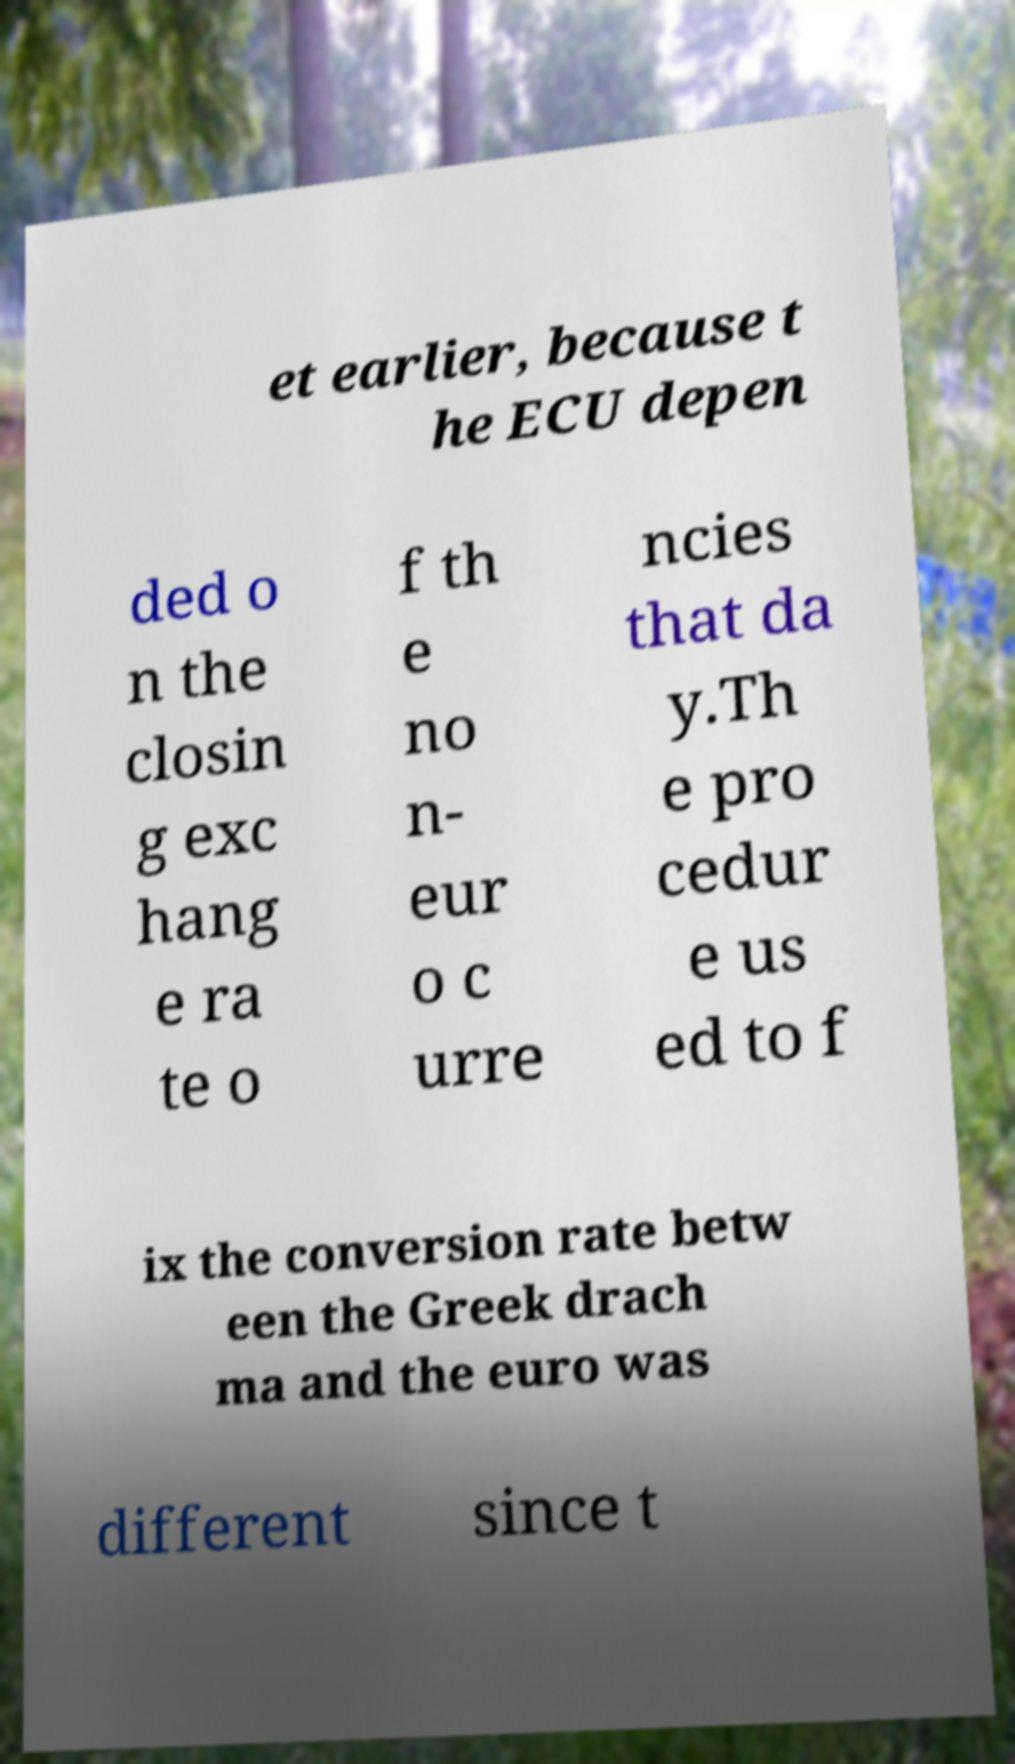Could you extract and type out the text from this image? et earlier, because t he ECU depen ded o n the closin g exc hang e ra te o f th e no n- eur o c urre ncies that da y.Th e pro cedur e us ed to f ix the conversion rate betw een the Greek drach ma and the euro was different since t 